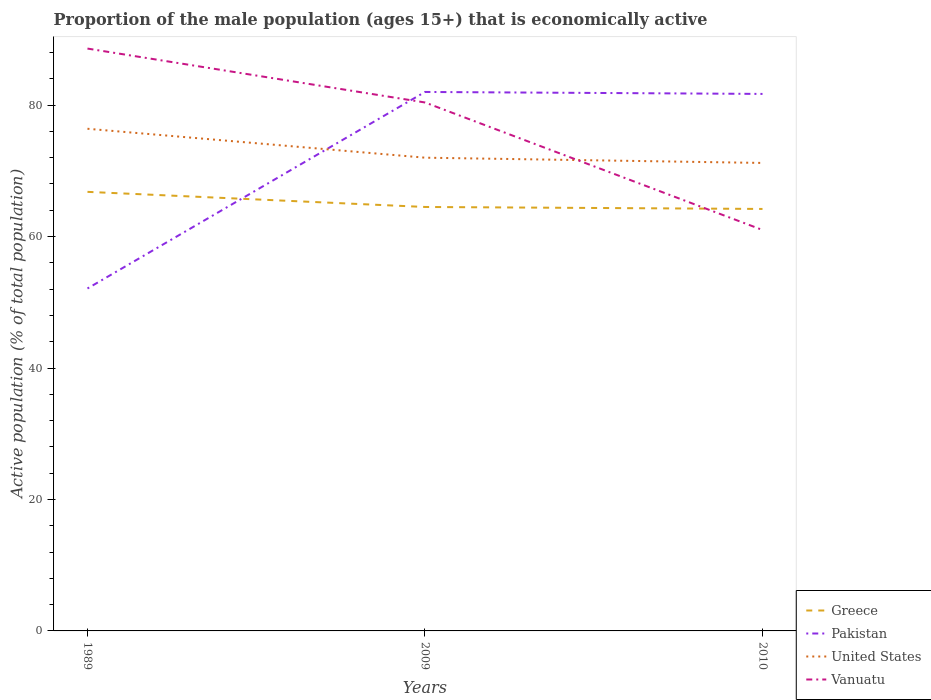How many different coloured lines are there?
Your answer should be compact. 4. Does the line corresponding to United States intersect with the line corresponding to Greece?
Your answer should be very brief. No. Across all years, what is the maximum proportion of the male population that is economically active in Vanuatu?
Your answer should be compact. 61. In which year was the proportion of the male population that is economically active in United States maximum?
Your answer should be very brief. 2010. What is the total proportion of the male population that is economically active in Greece in the graph?
Ensure brevity in your answer.  2.6. What is the difference between the highest and the second highest proportion of the male population that is economically active in Greece?
Your answer should be compact. 2.6. What is the difference between the highest and the lowest proportion of the male population that is economically active in Vanuatu?
Your response must be concise. 2. Is the proportion of the male population that is economically active in Greece strictly greater than the proportion of the male population that is economically active in Vanuatu over the years?
Keep it short and to the point. No. How many years are there in the graph?
Your answer should be compact. 3. What is the difference between two consecutive major ticks on the Y-axis?
Provide a succinct answer. 20. Does the graph contain any zero values?
Provide a succinct answer. No. Where does the legend appear in the graph?
Make the answer very short. Bottom right. How many legend labels are there?
Give a very brief answer. 4. What is the title of the graph?
Provide a succinct answer. Proportion of the male population (ages 15+) that is economically active. Does "Cameroon" appear as one of the legend labels in the graph?
Provide a short and direct response. No. What is the label or title of the X-axis?
Ensure brevity in your answer.  Years. What is the label or title of the Y-axis?
Give a very brief answer. Active population (% of total population). What is the Active population (% of total population) of Greece in 1989?
Offer a terse response. 66.8. What is the Active population (% of total population) of Pakistan in 1989?
Provide a succinct answer. 52.1. What is the Active population (% of total population) of United States in 1989?
Make the answer very short. 76.4. What is the Active population (% of total population) of Vanuatu in 1989?
Ensure brevity in your answer.  88.6. What is the Active population (% of total population) in Greece in 2009?
Provide a succinct answer. 64.5. What is the Active population (% of total population) in Vanuatu in 2009?
Offer a terse response. 80.4. What is the Active population (% of total population) in Greece in 2010?
Make the answer very short. 64.2. What is the Active population (% of total population) in Pakistan in 2010?
Give a very brief answer. 81.7. What is the Active population (% of total population) of United States in 2010?
Offer a very short reply. 71.2. What is the Active population (% of total population) in Vanuatu in 2010?
Your answer should be very brief. 61. Across all years, what is the maximum Active population (% of total population) of Greece?
Offer a very short reply. 66.8. Across all years, what is the maximum Active population (% of total population) in United States?
Provide a short and direct response. 76.4. Across all years, what is the maximum Active population (% of total population) in Vanuatu?
Provide a short and direct response. 88.6. Across all years, what is the minimum Active population (% of total population) of Greece?
Make the answer very short. 64.2. Across all years, what is the minimum Active population (% of total population) of Pakistan?
Keep it short and to the point. 52.1. Across all years, what is the minimum Active population (% of total population) of United States?
Your answer should be compact. 71.2. What is the total Active population (% of total population) of Greece in the graph?
Your answer should be very brief. 195.5. What is the total Active population (% of total population) of Pakistan in the graph?
Keep it short and to the point. 215.8. What is the total Active population (% of total population) in United States in the graph?
Offer a terse response. 219.6. What is the total Active population (% of total population) of Vanuatu in the graph?
Your answer should be very brief. 230. What is the difference between the Active population (% of total population) of Pakistan in 1989 and that in 2009?
Offer a terse response. -29.9. What is the difference between the Active population (% of total population) in Pakistan in 1989 and that in 2010?
Offer a terse response. -29.6. What is the difference between the Active population (% of total population) in Vanuatu in 1989 and that in 2010?
Offer a very short reply. 27.6. What is the difference between the Active population (% of total population) in Greece in 2009 and that in 2010?
Provide a succinct answer. 0.3. What is the difference between the Active population (% of total population) of Greece in 1989 and the Active population (% of total population) of Pakistan in 2009?
Keep it short and to the point. -15.2. What is the difference between the Active population (% of total population) of Greece in 1989 and the Active population (% of total population) of United States in 2009?
Keep it short and to the point. -5.2. What is the difference between the Active population (% of total population) of Greece in 1989 and the Active population (% of total population) of Vanuatu in 2009?
Make the answer very short. -13.6. What is the difference between the Active population (% of total population) of Pakistan in 1989 and the Active population (% of total population) of United States in 2009?
Offer a very short reply. -19.9. What is the difference between the Active population (% of total population) of Pakistan in 1989 and the Active population (% of total population) of Vanuatu in 2009?
Give a very brief answer. -28.3. What is the difference between the Active population (% of total population) of United States in 1989 and the Active population (% of total population) of Vanuatu in 2009?
Provide a short and direct response. -4. What is the difference between the Active population (% of total population) of Greece in 1989 and the Active population (% of total population) of Pakistan in 2010?
Offer a very short reply. -14.9. What is the difference between the Active population (% of total population) in Greece in 1989 and the Active population (% of total population) in United States in 2010?
Make the answer very short. -4.4. What is the difference between the Active population (% of total population) in Pakistan in 1989 and the Active population (% of total population) in United States in 2010?
Offer a very short reply. -19.1. What is the difference between the Active population (% of total population) in Pakistan in 1989 and the Active population (% of total population) in Vanuatu in 2010?
Give a very brief answer. -8.9. What is the difference between the Active population (% of total population) in United States in 1989 and the Active population (% of total population) in Vanuatu in 2010?
Keep it short and to the point. 15.4. What is the difference between the Active population (% of total population) of Greece in 2009 and the Active population (% of total population) of Pakistan in 2010?
Offer a very short reply. -17.2. What is the difference between the Active population (% of total population) of Greece in 2009 and the Active population (% of total population) of United States in 2010?
Offer a terse response. -6.7. What is the difference between the Active population (% of total population) of Pakistan in 2009 and the Active population (% of total population) of United States in 2010?
Provide a short and direct response. 10.8. What is the difference between the Active population (% of total population) in Pakistan in 2009 and the Active population (% of total population) in Vanuatu in 2010?
Your answer should be very brief. 21. What is the average Active population (% of total population) of Greece per year?
Make the answer very short. 65.17. What is the average Active population (% of total population) of Pakistan per year?
Provide a succinct answer. 71.93. What is the average Active population (% of total population) in United States per year?
Give a very brief answer. 73.2. What is the average Active population (% of total population) of Vanuatu per year?
Provide a succinct answer. 76.67. In the year 1989, what is the difference between the Active population (% of total population) in Greece and Active population (% of total population) in United States?
Give a very brief answer. -9.6. In the year 1989, what is the difference between the Active population (% of total population) in Greece and Active population (% of total population) in Vanuatu?
Your answer should be compact. -21.8. In the year 1989, what is the difference between the Active population (% of total population) in Pakistan and Active population (% of total population) in United States?
Offer a terse response. -24.3. In the year 1989, what is the difference between the Active population (% of total population) of Pakistan and Active population (% of total population) of Vanuatu?
Ensure brevity in your answer.  -36.5. In the year 2009, what is the difference between the Active population (% of total population) in Greece and Active population (% of total population) in Pakistan?
Give a very brief answer. -17.5. In the year 2009, what is the difference between the Active population (% of total population) of Greece and Active population (% of total population) of Vanuatu?
Offer a very short reply. -15.9. In the year 2009, what is the difference between the Active population (% of total population) in Pakistan and Active population (% of total population) in United States?
Keep it short and to the point. 10. In the year 2009, what is the difference between the Active population (% of total population) of United States and Active population (% of total population) of Vanuatu?
Offer a terse response. -8.4. In the year 2010, what is the difference between the Active population (% of total population) in Greece and Active population (% of total population) in Pakistan?
Make the answer very short. -17.5. In the year 2010, what is the difference between the Active population (% of total population) in Greece and Active population (% of total population) in United States?
Make the answer very short. -7. In the year 2010, what is the difference between the Active population (% of total population) of Greece and Active population (% of total population) of Vanuatu?
Your answer should be very brief. 3.2. In the year 2010, what is the difference between the Active population (% of total population) of Pakistan and Active population (% of total population) of United States?
Provide a short and direct response. 10.5. In the year 2010, what is the difference between the Active population (% of total population) of Pakistan and Active population (% of total population) of Vanuatu?
Your answer should be very brief. 20.7. In the year 2010, what is the difference between the Active population (% of total population) of United States and Active population (% of total population) of Vanuatu?
Keep it short and to the point. 10.2. What is the ratio of the Active population (% of total population) of Greece in 1989 to that in 2009?
Offer a terse response. 1.04. What is the ratio of the Active population (% of total population) of Pakistan in 1989 to that in 2009?
Offer a terse response. 0.64. What is the ratio of the Active population (% of total population) of United States in 1989 to that in 2009?
Your answer should be very brief. 1.06. What is the ratio of the Active population (% of total population) of Vanuatu in 1989 to that in 2009?
Provide a succinct answer. 1.1. What is the ratio of the Active population (% of total population) of Greece in 1989 to that in 2010?
Offer a very short reply. 1.04. What is the ratio of the Active population (% of total population) of Pakistan in 1989 to that in 2010?
Offer a very short reply. 0.64. What is the ratio of the Active population (% of total population) in United States in 1989 to that in 2010?
Provide a short and direct response. 1.07. What is the ratio of the Active population (% of total population) in Vanuatu in 1989 to that in 2010?
Make the answer very short. 1.45. What is the ratio of the Active population (% of total population) of Greece in 2009 to that in 2010?
Keep it short and to the point. 1. What is the ratio of the Active population (% of total population) of United States in 2009 to that in 2010?
Provide a succinct answer. 1.01. What is the ratio of the Active population (% of total population) of Vanuatu in 2009 to that in 2010?
Make the answer very short. 1.32. What is the difference between the highest and the second highest Active population (% of total population) of Pakistan?
Provide a succinct answer. 0.3. What is the difference between the highest and the second highest Active population (% of total population) of United States?
Make the answer very short. 4.4. What is the difference between the highest and the lowest Active population (% of total population) in Pakistan?
Ensure brevity in your answer.  29.9. What is the difference between the highest and the lowest Active population (% of total population) in Vanuatu?
Offer a very short reply. 27.6. 